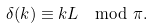<formula> <loc_0><loc_0><loc_500><loc_500>\delta ( k ) \equiv k L \mod \pi .</formula> 